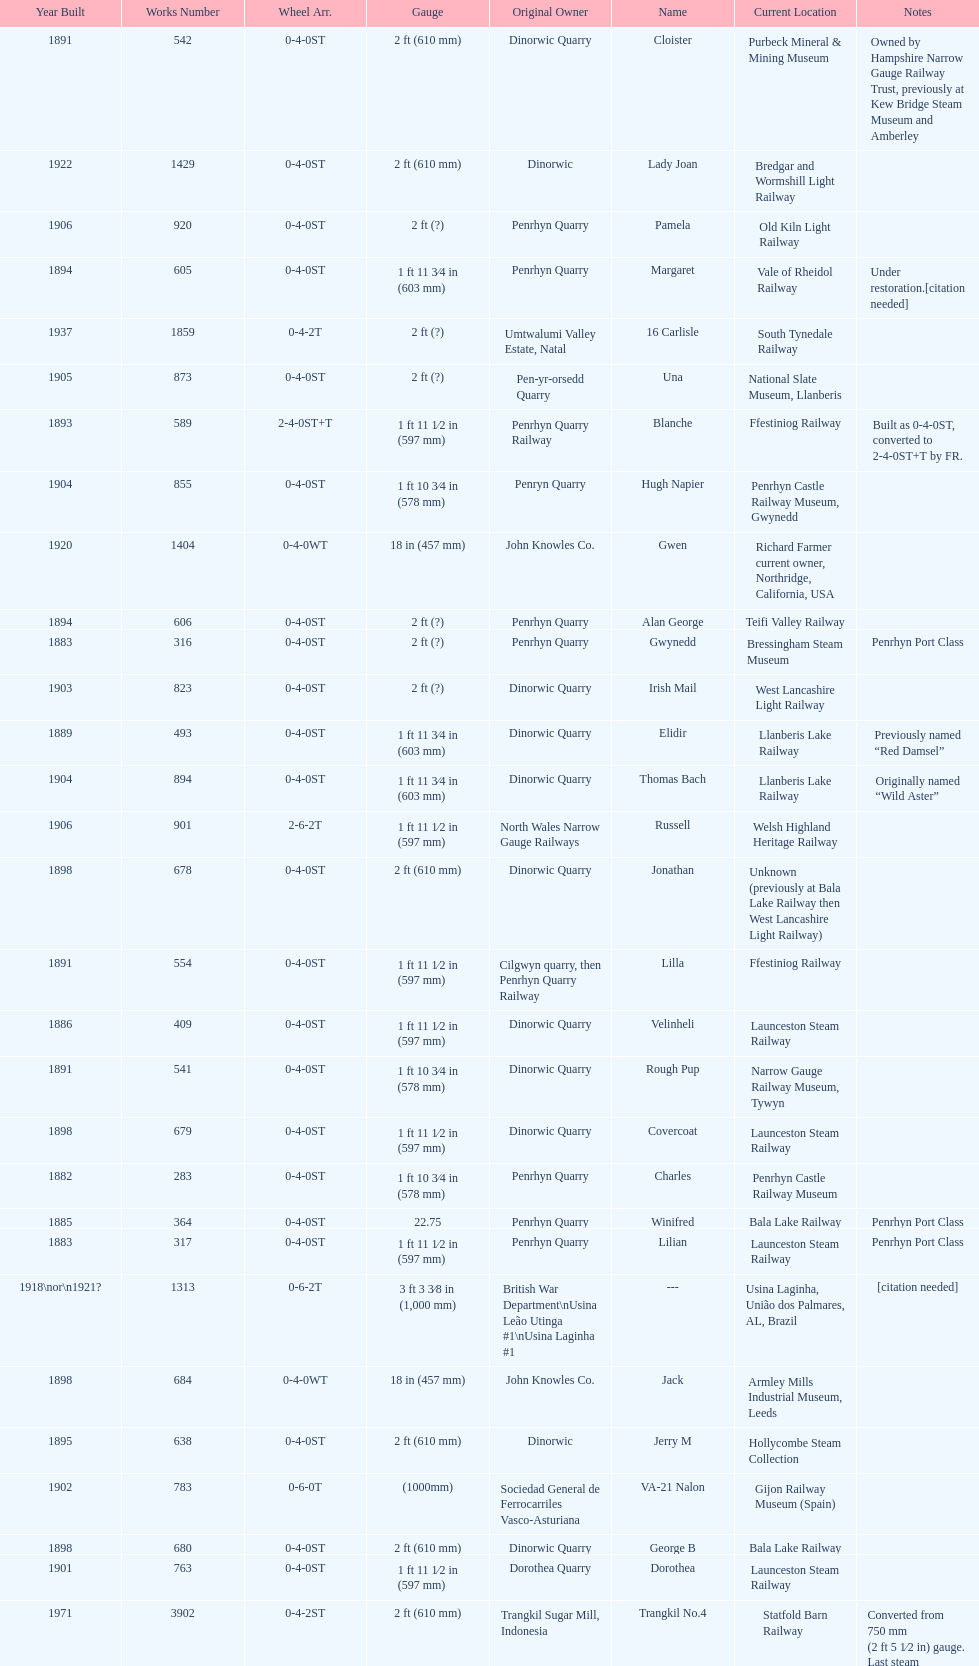Could you help me parse every detail presented in this table? {'header': ['Year Built', 'Works Number', 'Wheel Arr.', 'Gauge', 'Original Owner', 'Name', 'Current Location', 'Notes'], 'rows': [['1891', '542', '0-4-0ST', '2\xa0ft (610\xa0mm)', 'Dinorwic Quarry', 'Cloister', 'Purbeck Mineral & Mining Museum', 'Owned by Hampshire Narrow Gauge Railway Trust, previously at Kew Bridge Steam Museum and Amberley'], ['1922', '1429', '0-4-0ST', '2\xa0ft (610\xa0mm)', 'Dinorwic', 'Lady Joan', 'Bredgar and Wormshill Light Railway', ''], ['1906', '920', '0-4-0ST', '2\xa0ft (?)', 'Penrhyn Quarry', 'Pamela', 'Old Kiln Light Railway', ''], ['1894', '605', '0-4-0ST', '1\xa0ft 11\xa03⁄4\xa0in (603\xa0mm)', 'Penrhyn Quarry', 'Margaret', 'Vale of Rheidol Railway', 'Under restoration.[citation needed]'], ['1937', '1859', '0-4-2T', '2\xa0ft (?)', 'Umtwalumi Valley Estate, Natal', '16 Carlisle', 'South Tynedale Railway', ''], ['1905', '873', '0-4-0ST', '2\xa0ft (?)', 'Pen-yr-orsedd Quarry', 'Una', 'National Slate Museum, Llanberis', ''], ['1893', '589', '2-4-0ST+T', '1\xa0ft 11\xa01⁄2\xa0in (597\xa0mm)', 'Penrhyn Quarry Railway', 'Blanche', 'Ffestiniog Railway', 'Built as 0-4-0ST, converted to 2-4-0ST+T by FR.'], ['1904', '855', '0-4-0ST', '1\xa0ft 10\xa03⁄4\xa0in (578\xa0mm)', 'Penryn Quarry', 'Hugh Napier', 'Penrhyn Castle Railway Museum, Gwynedd', ''], ['1920', '1404', '0-4-0WT', '18\xa0in (457\xa0mm)', 'John Knowles Co.', 'Gwen', 'Richard Farmer current owner, Northridge, California, USA', ''], ['1894', '606', '0-4-0ST', '2\xa0ft (?)', 'Penrhyn Quarry', 'Alan George', 'Teifi Valley Railway', ''], ['1883', '316', '0-4-0ST', '2\xa0ft (?)', 'Penrhyn Quarry', 'Gwynedd', 'Bressingham Steam Museum', 'Penrhyn Port Class'], ['1903', '823', '0-4-0ST', '2\xa0ft (?)', 'Dinorwic Quarry', 'Irish Mail', 'West Lancashire Light Railway', ''], ['1889', '493', '0-4-0ST', '1\xa0ft 11\xa03⁄4\xa0in (603\xa0mm)', 'Dinorwic Quarry', 'Elidir', 'Llanberis Lake Railway', 'Previously named “Red Damsel”'], ['1904', '894', '0-4-0ST', '1\xa0ft 11\xa03⁄4\xa0in (603\xa0mm)', 'Dinorwic Quarry', 'Thomas Bach', 'Llanberis Lake Railway', 'Originally named “Wild Aster”'], ['1906', '901', '2-6-2T', '1\xa0ft 11\xa01⁄2\xa0in (597\xa0mm)', 'North Wales Narrow Gauge Railways', 'Russell', 'Welsh Highland Heritage Railway', ''], ['1898', '678', '0-4-0ST', '2\xa0ft (610\xa0mm)', 'Dinorwic Quarry', 'Jonathan', 'Unknown (previously at Bala Lake Railway then West Lancashire Light Railway)', ''], ['1891', '554', '0-4-0ST', '1\xa0ft 11\xa01⁄2\xa0in (597\xa0mm)', 'Cilgwyn quarry, then Penrhyn Quarry Railway', 'Lilla', 'Ffestiniog Railway', ''], ['1886', '409', '0-4-0ST', '1\xa0ft 11\xa01⁄2\xa0in (597\xa0mm)', 'Dinorwic Quarry', 'Velinheli', 'Launceston Steam Railway', ''], ['1891', '541', '0-4-0ST', '1\xa0ft 10\xa03⁄4\xa0in (578\xa0mm)', 'Dinorwic Quarry', 'Rough Pup', 'Narrow Gauge Railway Museum, Tywyn', ''], ['1898', '679', '0-4-0ST', '1\xa0ft 11\xa01⁄2\xa0in (597\xa0mm)', 'Dinorwic Quarry', 'Covercoat', 'Launceston Steam Railway', ''], ['1882', '283', '0-4-0ST', '1\xa0ft 10\xa03⁄4\xa0in (578\xa0mm)', 'Penrhyn Quarry', 'Charles', 'Penrhyn Castle Railway Museum', ''], ['1885', '364', '0-4-0ST', '22.75', 'Penrhyn Quarry', 'Winifred', 'Bala Lake Railway', 'Penrhyn Port Class'], ['1883', '317', '0-4-0ST', '1\xa0ft 11\xa01⁄2\xa0in (597\xa0mm)', 'Penrhyn Quarry', 'Lilian', 'Launceston Steam Railway', 'Penrhyn Port Class'], ['1918\\nor\\n1921?', '1313', '0-6-2T', '3\xa0ft\xa03\xa03⁄8\xa0in (1,000\xa0mm)', 'British War Department\\nUsina Leão Utinga #1\\nUsina Laginha #1', '---', 'Usina Laginha, União dos Palmares, AL, Brazil', '[citation needed]'], ['1898', '684', '0-4-0WT', '18\xa0in (457\xa0mm)', 'John Knowles Co.', 'Jack', 'Armley Mills Industrial Museum, Leeds', ''], ['1895', '638', '0-4-0ST', '2\xa0ft (610\xa0mm)', 'Dinorwic', 'Jerry M', 'Hollycombe Steam Collection', ''], ['1902', '783', '0-6-0T', '(1000mm)', 'Sociedad General de Ferrocarriles Vasco-Asturiana', 'VA-21 Nalon', 'Gijon Railway Museum (Spain)', ''], ['1898', '680', '0-4-0ST', '2\xa0ft (610\xa0mm)', 'Dinorwic Quarry', 'George B', 'Bala Lake Railway', ''], ['1901', '763', '0-4-0ST', '1\xa0ft 11\xa01⁄2\xa0in (597\xa0mm)', 'Dorothea Quarry', 'Dorothea', 'Launceston Steam Railway', ''], ['1971', '3902', '0-4-2ST', '2\xa0ft (610\xa0mm)', 'Trangkil Sugar Mill, Indonesia', 'Trangkil No.4', 'Statfold Barn Railway', 'Converted from 750\xa0mm (2\xa0ft\xa05\xa01⁄2\xa0in) gauge. Last steam locomotive to be built by Hunslet, and the last industrial steam locomotive built in Britain.'], ['1899', '705', '0-4-0ST', '2\xa0ft (610\xa0mm)', 'Penrhyn Quarry', 'Elin', 'Yaxham Light Railway', 'Previously at the Lincolnshire Coast Light Railway.'], ['1903', '827', '0-4-0ST', '1\xa0ft 11\xa03⁄4\xa0in (603\xa0mm)', 'Pen-yr-orsedd Quarry', 'Sybil', 'Brecon Mountain Railway', ''], ['1893', '590', '2-4-0ST+T', '1\xa0ft 11\xa01⁄2\xa0in (597\xa0mm)', 'Penrhyn Quarry Railway', 'Linda', 'Ffestiniog Railway', 'Built as 0-4-0ST, converted to 2-4-0ST+T by FR.'], ['1954', '3815', '2-6-2T', '2\xa0ft 6\xa0in (762\xa0mm)', 'Sierra Leone Government Railway', '14', 'Welshpool and Llanfair Light Railway', ''], ['1899', '707', '0-4-0ST', '1\xa0ft 11\xa01⁄2\xa0in (597\xa0mm)', 'Pen-yr-orsedd Quarry', 'Britomart', 'Ffestiniog Railway', ''], ['1902', '779', '0-4-0ST', '2\xa0ft (610\xa0mm)', 'Dinorwic Quarry', 'Holy War', 'Bala Lake Railway', ''], ['1903', '822', '0-4-0ST', '2\xa0ft (610\xa0mm)', 'Dinorwic Quarry', 'Maid Marian', 'Bala Lake Railway', ''], ['1890', '518', '2-2-0T', '(1000mm)', 'S.V.T. 8', 'Tortosa-La Cava1', 'Tortosa (catalonia, Spain)', ''], ['1918', '1312', '4-6-0T', '1\xa0ft\xa011\xa01⁄2\xa0in (597\xa0mm)', 'British War Department\\nEFOP #203', '---', 'Pampas Safari, Gravataí, RS, Brazil', '[citation needed]'], ['1922', '1430', '0-4-0ST', '1\xa0ft 11\xa03⁄4\xa0in (603\xa0mm)', 'Dinorwic Quarry', 'Dolbadarn', 'Llanberis Lake Railway', ''], ['1940', '2075', '0-4-2T', '2\xa0ft (?)', 'Chaka’s Kraal Sugar Estates, Natal', 'Chaka’s Kraal No. 6', 'North Gloucestershire Railway', ''], ['1909', '994', '0-4-0ST', '2\xa0ft (?)', 'Penrhyn Quarry', 'Bill Harvey', 'Bressingham Steam Museum', 'previously George Sholto'], ['1902', '780', '0-4-0ST', '2\xa0ft (610\xa0mm)', 'Dinorwic Quarry', 'Alice', 'Bala Lake Railway', ''], ['1896', '652', '0-4-0ST', '1\xa0ft 11\xa01⁄2\xa0in (597\xa0mm)', 'Groby Granite, then Dinorwic Quarry', 'Lady Madcap', 'Welsh Highland Heritage Railway', 'Originally named Sextus.']]} In which year were the most steam locomotives built? 1898. 